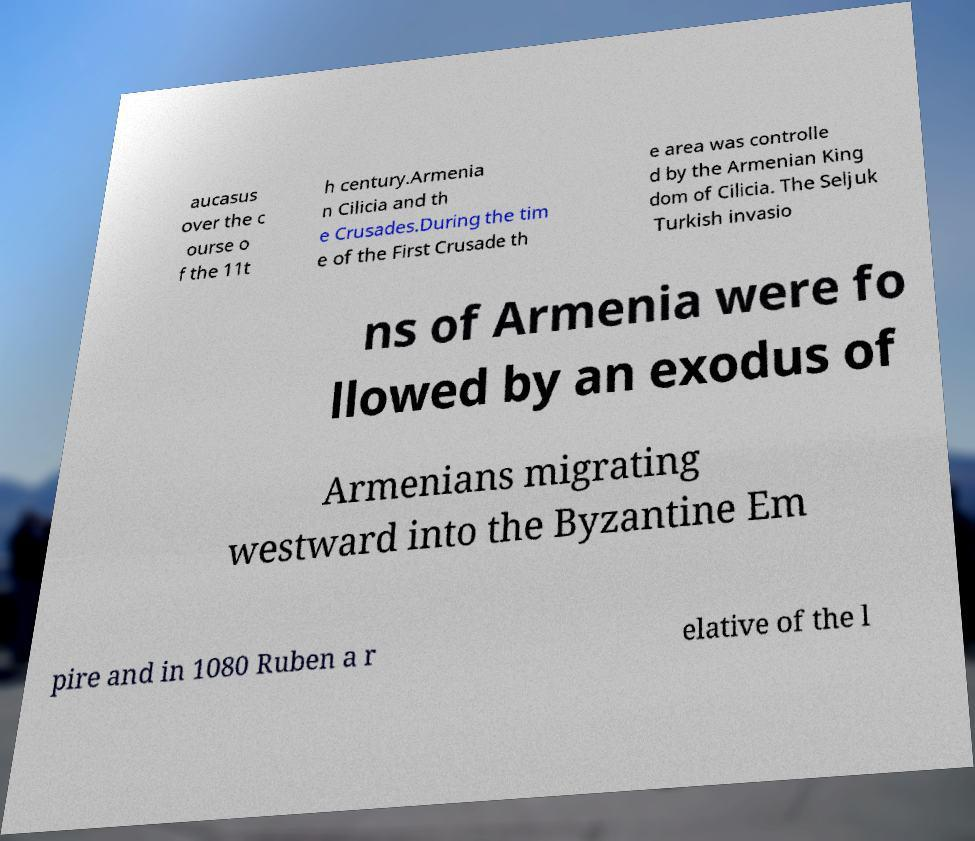Can you accurately transcribe the text from the provided image for me? aucasus over the c ourse o f the 11t h century.Armenia n Cilicia and th e Crusades.During the tim e of the First Crusade th e area was controlle d by the Armenian King dom of Cilicia. The Seljuk Turkish invasio ns of Armenia were fo llowed by an exodus of Armenians migrating westward into the Byzantine Em pire and in 1080 Ruben a r elative of the l 